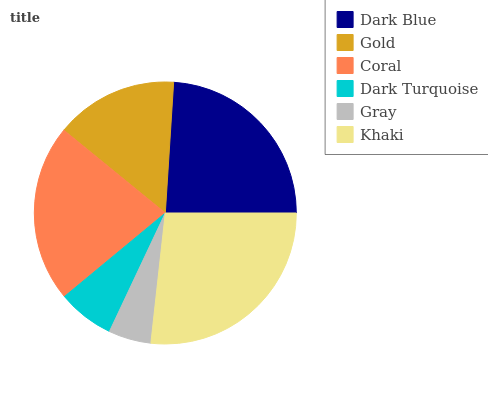Is Gray the minimum?
Answer yes or no. Yes. Is Khaki the maximum?
Answer yes or no. Yes. Is Gold the minimum?
Answer yes or no. No. Is Gold the maximum?
Answer yes or no. No. Is Dark Blue greater than Gold?
Answer yes or no. Yes. Is Gold less than Dark Blue?
Answer yes or no. Yes. Is Gold greater than Dark Blue?
Answer yes or no. No. Is Dark Blue less than Gold?
Answer yes or no. No. Is Coral the high median?
Answer yes or no. Yes. Is Gold the low median?
Answer yes or no. Yes. Is Gold the high median?
Answer yes or no. No. Is Dark Blue the low median?
Answer yes or no. No. 